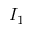Convert formula to latex. <formula><loc_0><loc_0><loc_500><loc_500>I _ { 1 }</formula> 